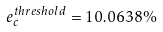Convert formula to latex. <formula><loc_0><loc_0><loc_500><loc_500>e _ { c } ^ { t h r e s h o l d } = 1 0 . 0 6 3 8 \%</formula> 